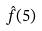Convert formula to latex. <formula><loc_0><loc_0><loc_500><loc_500>\hat { f } ( 5 )</formula> 